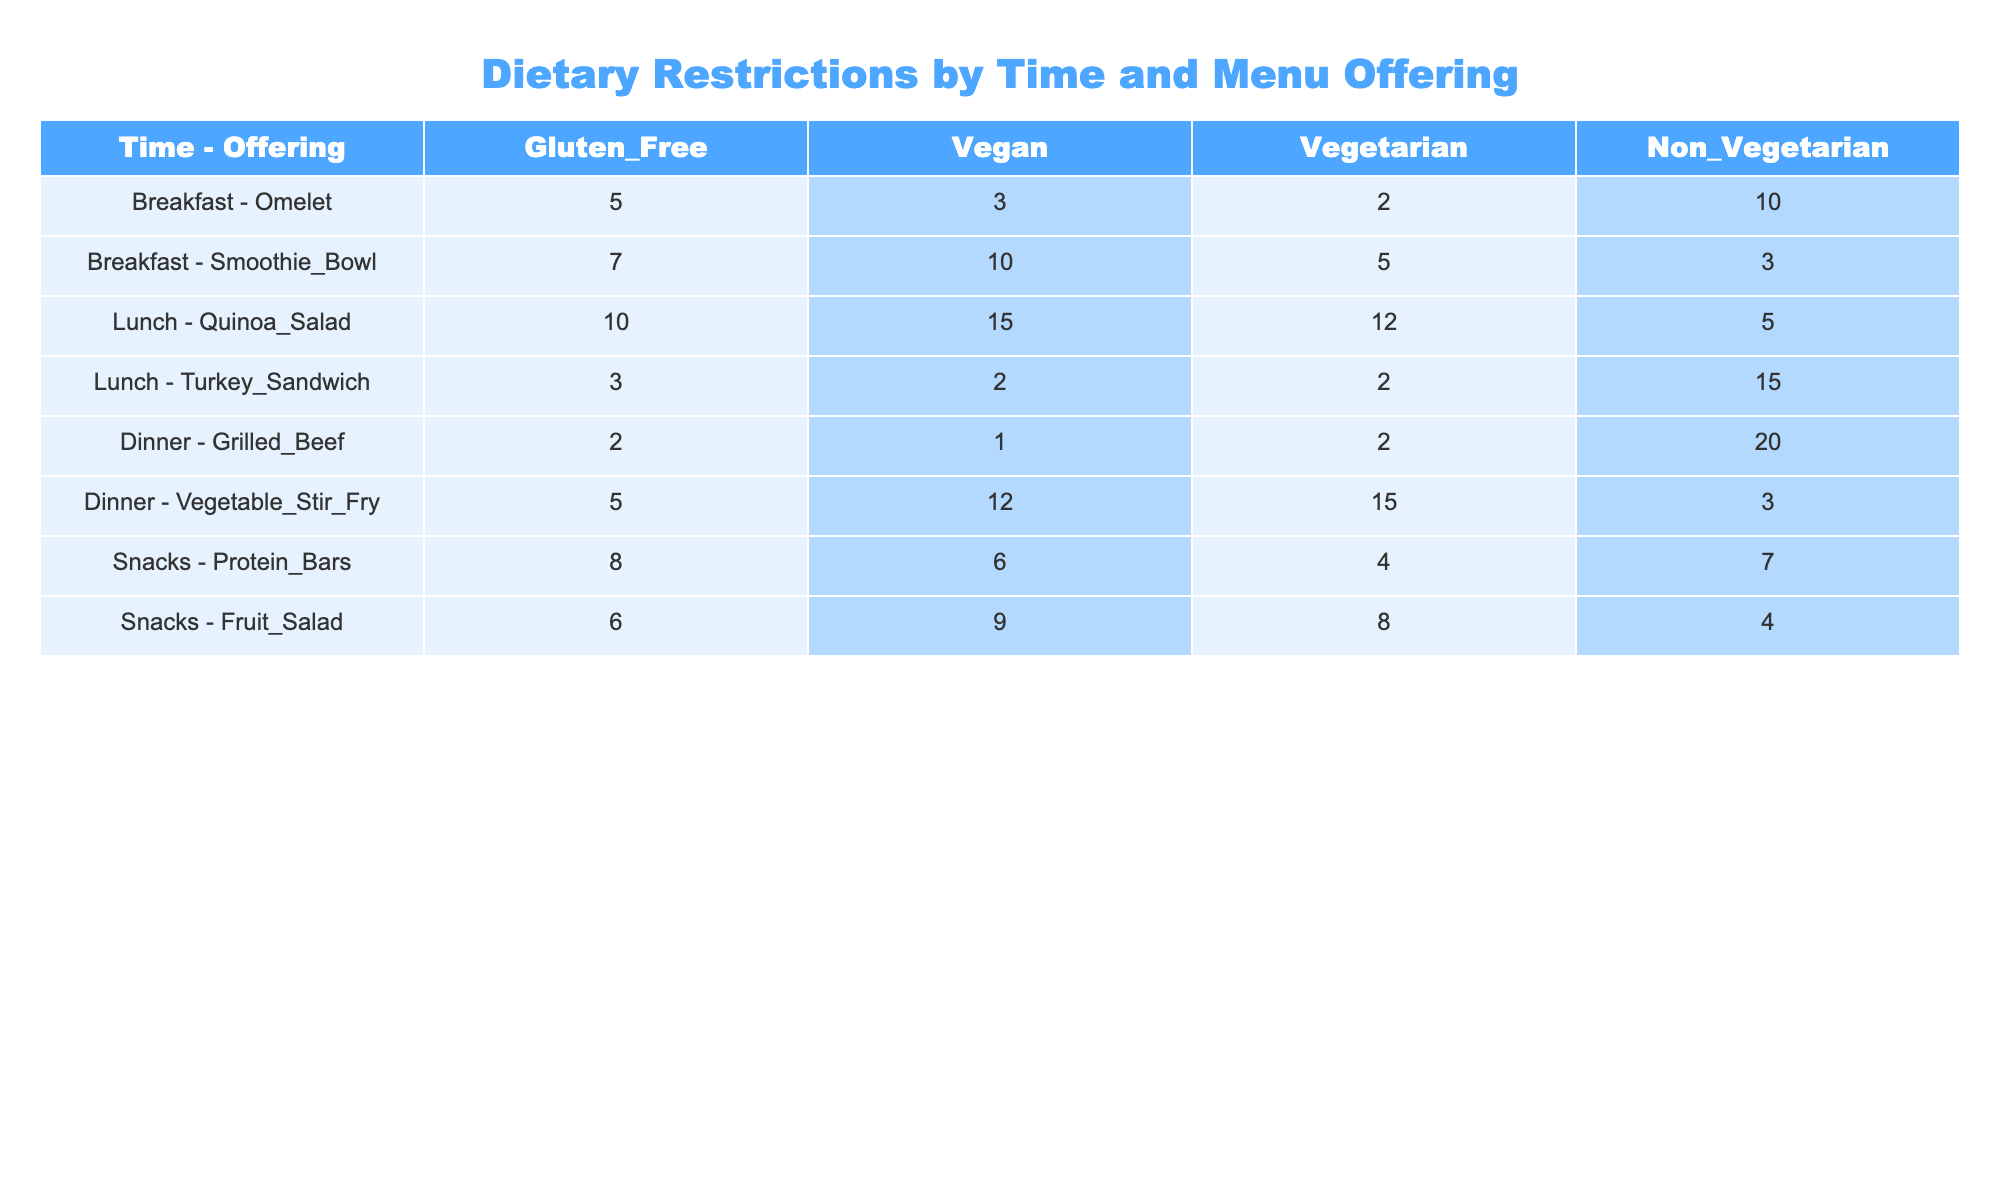What menu offering has the highest number of gluten-free options? In the table, I look through the "Gluten_Free" column for the highest number. The "Quinoa_Salad" has 10 gluten-free options, which is higher than any other menu offering.
Answer: Quinoa_Salad How many vegan options are available for lunch? I find the rows corresponding to lunch in the table and add the vegan options: Turkey_Sandwich (2) + Quinoa_Salad (15) = 17 vegan options total.
Answer: 17 Is there a vegan option in the Dinner menu? I check the "Vegan" column for the Dinner offerings. Both "Grilled_Beef" and "Vegetable_Stir_Fry" are present, and the "Vegetable_Stir_Fry" has 12 vegan options. This confirms there is at least one vegan option available.
Answer: Yes What is the total number of non-vegetarian options across all meals? I sum the "Non_Vegetarian" column values: 10 (Omelet) + 3 (Smoothie_Bowl) + 15 (Turkey_Sandwich) + 20 (Grilled_Beef) + 3 (Vegetable_Stir_Fry) + 7 (Protein_Bars) + 4 (Fruit_Salad) = 62.
Answer: 62 Which time of day has the highest number of vegetarian options in total? I calculate the total vegetarian options for each time of day: Breakfast (2 + 5 = 7), Lunch (12 + 2 = 14), Dinner (2 + 15 = 17), Snacks (4 + 8 = 12). The Dinner has the highest total with 17 vegetarian options.
Answer: Dinner Have any menu offerings during breakfast surpassed 10 options in any dietary category? I check the Breakfast offerings: Omelet (5 gluten-free, 3 vegan) and Smoothie_Bowl (7 gluten-free, 10 vegan). The Smoothie_Bowl has 10 vegan options, which surpasses 10 in that category.
Answer: Yes What is the average number of vegetarian options across all meals? I compute the average by first summing the vegetarian options in each offering: 2 (Omelet) + 5 (Smoothie_Bowl) + 12 (Quinoa_Salad) + 2 (Turkey_Sandwich) + 2 (Grilled_Beef) + 15 (Vegetable_Stir_Fry) + 4 (Protein_Bars) + 8 (Fruit_Salad) = 50. There are 8 meal offerings, so the average is 50/8 = 6.25.
Answer: 6.25 How many total options are vegetarian for Snacks compared to Lunch? I check the vegetarian counts for Snacks (4 + 8 = 12) and Lunch (12 + 2 = 14). I find that Lunch has more vegetarian options than Snacks (14 > 12).
Answer: Lunch has more vegetarian options Which meal offering has the lowest prevalence of gluten-free options? I examine the "Gluten_Free" column for the lowest number: "Grilled_Beef" has only 2 gluten-free options, which is the least compared to others.
Answer: Grilled_Beef 